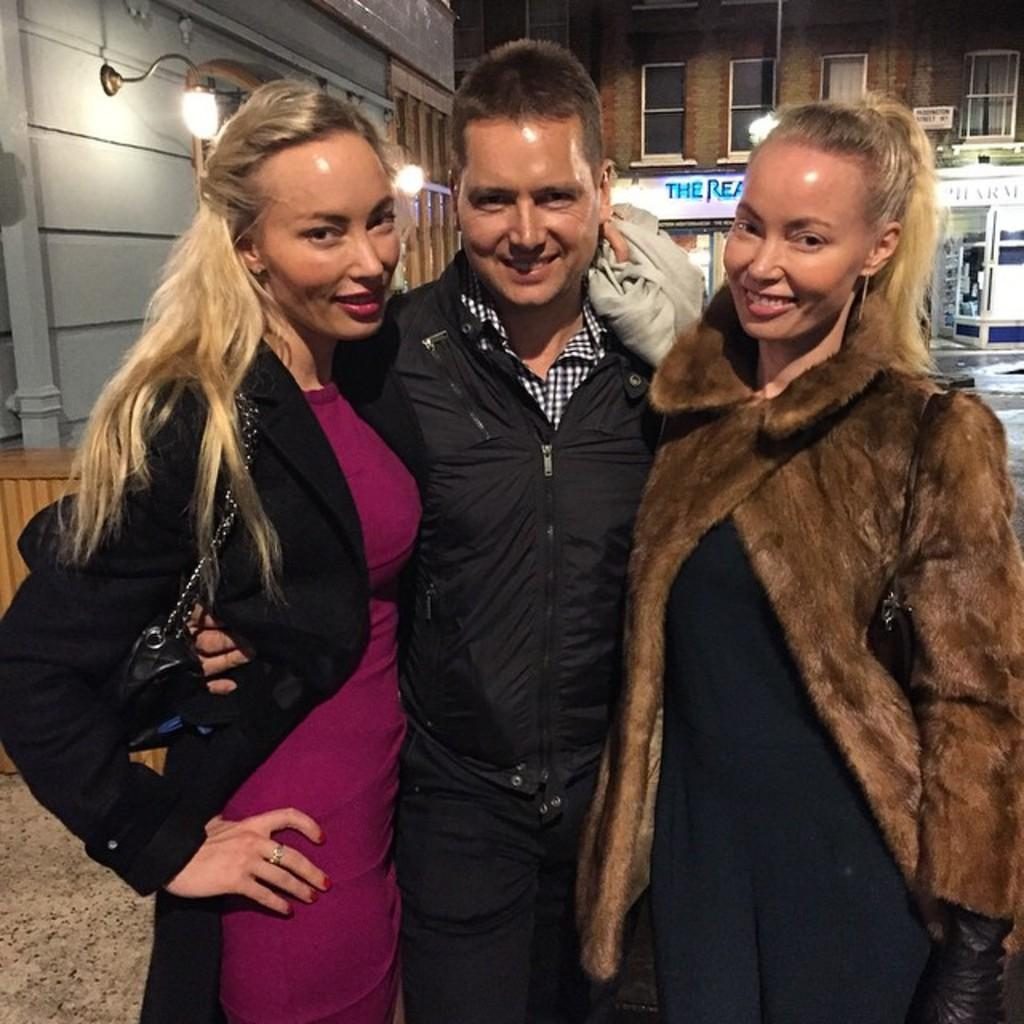How many people are in the image? There are three people in the image: one man and two women. What are the expressions on the faces of the people in the image? The man and women are smiling in the image. What can be seen in the background of the image? There are buildings, lights, and hoardings visible in the background of the image. What type of agreement is being discussed by the babies in the image? There are no babies present in the image; it features a man and two women. What arithmetic problem is being solved by the hoardings in the image? The hoardings in the image are not solving any arithmetic problems; they are simply advertisements or signs. 